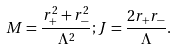<formula> <loc_0><loc_0><loc_500><loc_500>M = \frac { r _ { + } ^ { 2 } + r _ { - } ^ { 2 } } { \Lambda ^ { 2 } } ; J = \frac { 2 r _ { + } r _ { - } } { \Lambda } .</formula> 